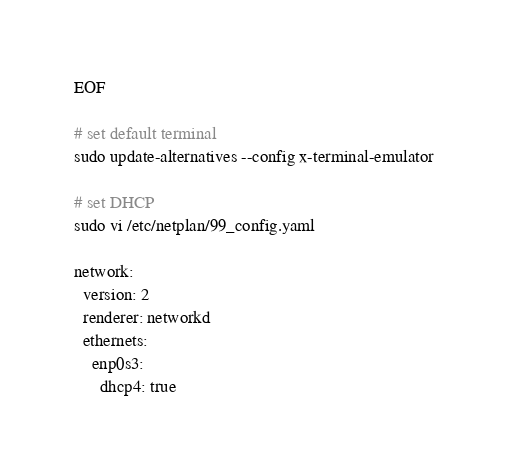Convert code to text. <code><loc_0><loc_0><loc_500><loc_500><_Bash_>EOF

# set default terminal
sudo update-alternatives --config x-terminal-emulator

# set DHCP
sudo vi /etc/netplan/99_config.yaml

network:
  version: 2
  renderer: networkd
  ethernets:
    enp0s3:
      dhcp4: true</code> 